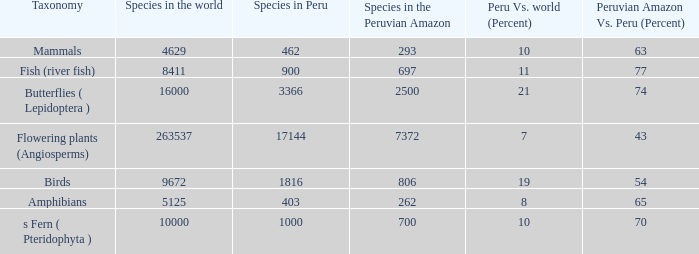What's the total number of species in the peruvian amazon with 8411 species in the world  1.0. 